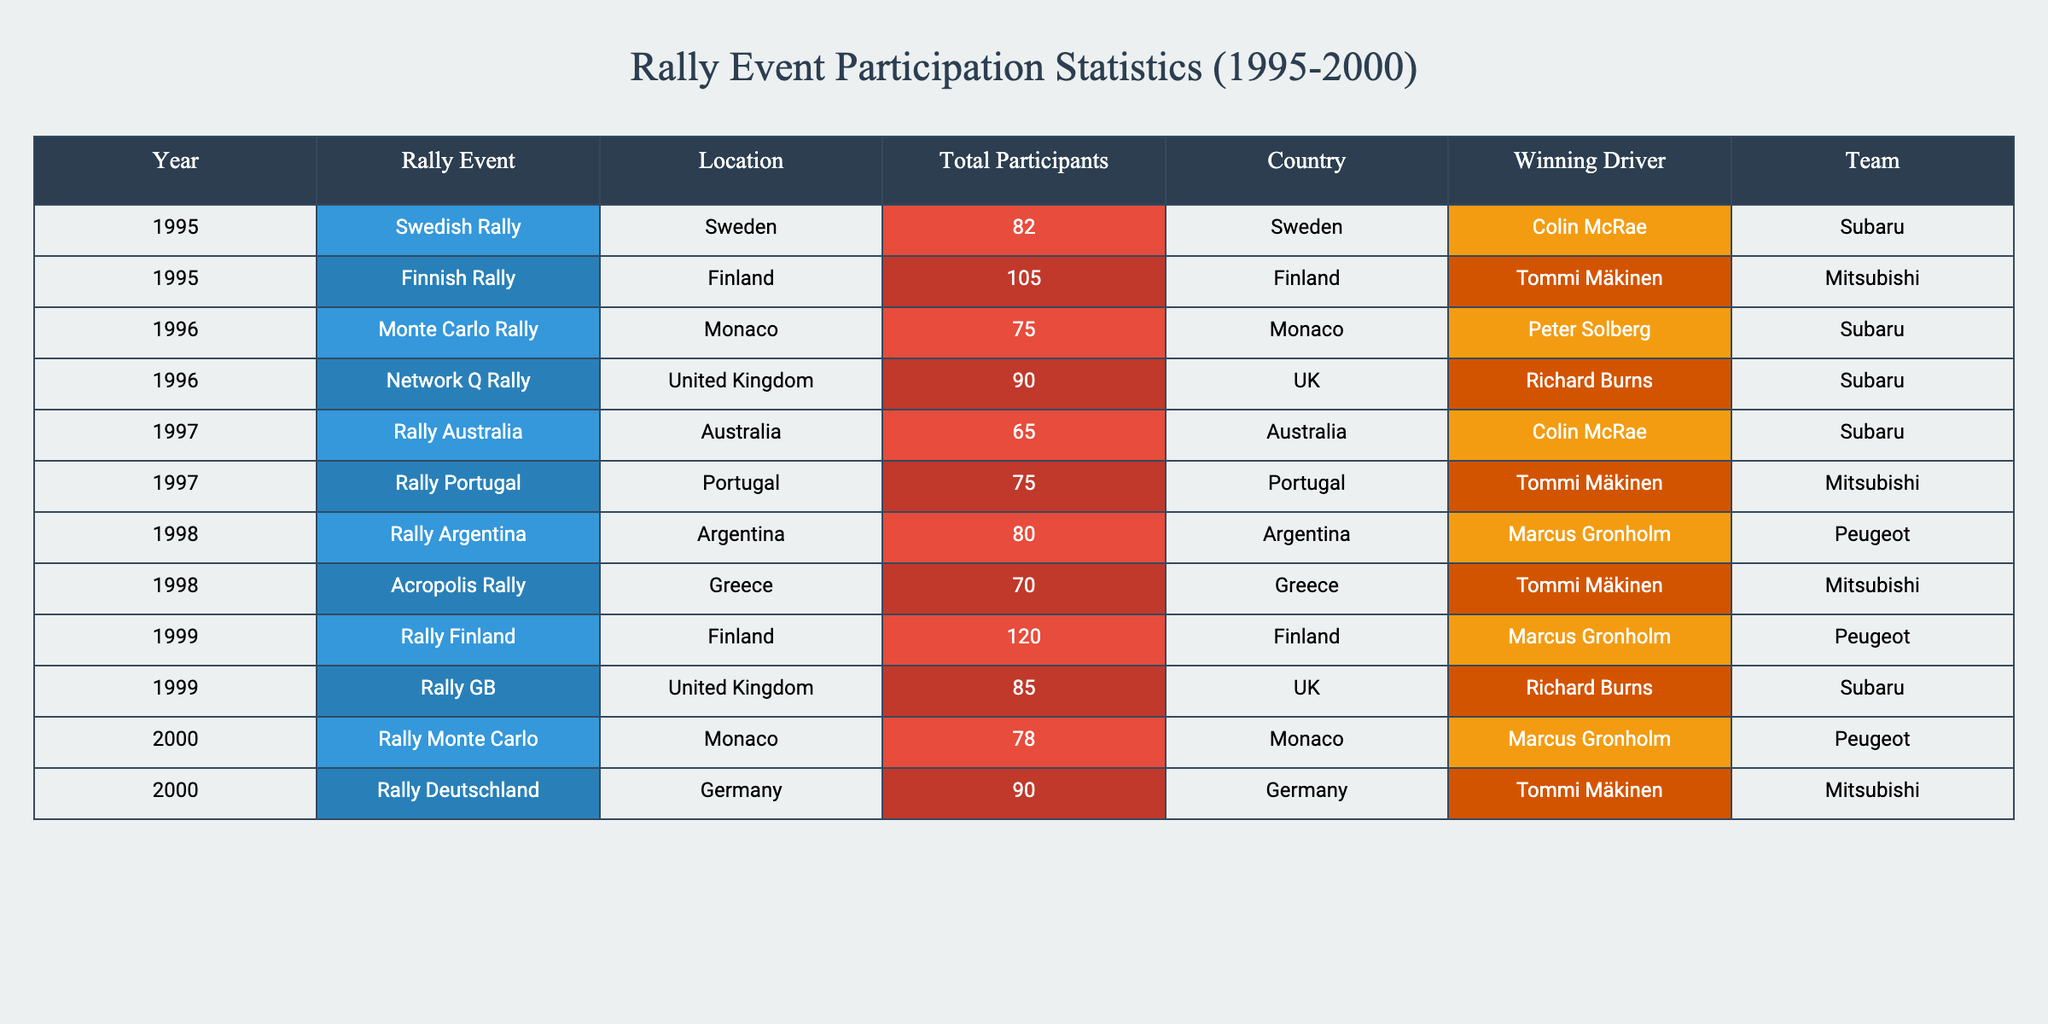What was the total number of participants in Rally Australia in 1997? The table shows that the Total Participants in Rally Australia in 1997 is directly listed as 65.
Answer: 65 Which rally event had the highest number of participants across the years listed? By examining the Total Participants column, the highest value is 120 from the 1999 Rally Finland.
Answer: 120 Did any rally event in 1996 have more participants than Rally Australia in 1997? Comparing the Total Participants from 1996, the Monte Carlo Rally had 75 participants and the Network Q Rally had 90 participants. Both are greater than the 65 from Rally Australia.
Answer: Yes What is the average number of participants for the rally events held in 1998? For 1998, the Rally Argentina had 80 participants and the Acropolis Rally had 70 participants. Adding these gives a total of 150, and dividing by 2 for an average results in 75.
Answer: 75 Which country hosted the rally event with the most participants from 1995 to 2000? Looking through the Country column, Finland hosted the Rally Finland in 1999, which had the highest participants at 120, making it the host country of the most well-attended event.
Answer: Finland How many more participants did the Finnish Rally in 1995 have compared to the Rally Portugal in 1997? The Finnish Rally in 1995 had 105 participants while the Rally Portugal in 1997 had 75 participants. The difference is 105 - 75 = 30 participants.
Answer: 30 Was the winning driver for the Rally Australia in 1997 different from the winning driver of the Monte Carlo Rally in 1996? Upon checking the Winning Driver column, Colin McRae won the Rally Australia in 1997, while Peter Solberg won the Monte Carlo Rally in 1996. These two drivers are different.
Answer: Yes Which rally event experienced a decrease in participants from 1996 to 1997? In 1996, the Network Q Rally had 90 participants but Rally Australia in 1997 had only 65 participants. The decrease is thus 90 - 65 = 25 participants.
Answer: 25 What was the total number of participants across all rally events mentioned in the year 1999? From the year 1999, there were two events: Rally Finland with 120 participants and Rally GB with 85 participants. Adding these gives a total of 120 + 85 = 205 participants.
Answer: 205 